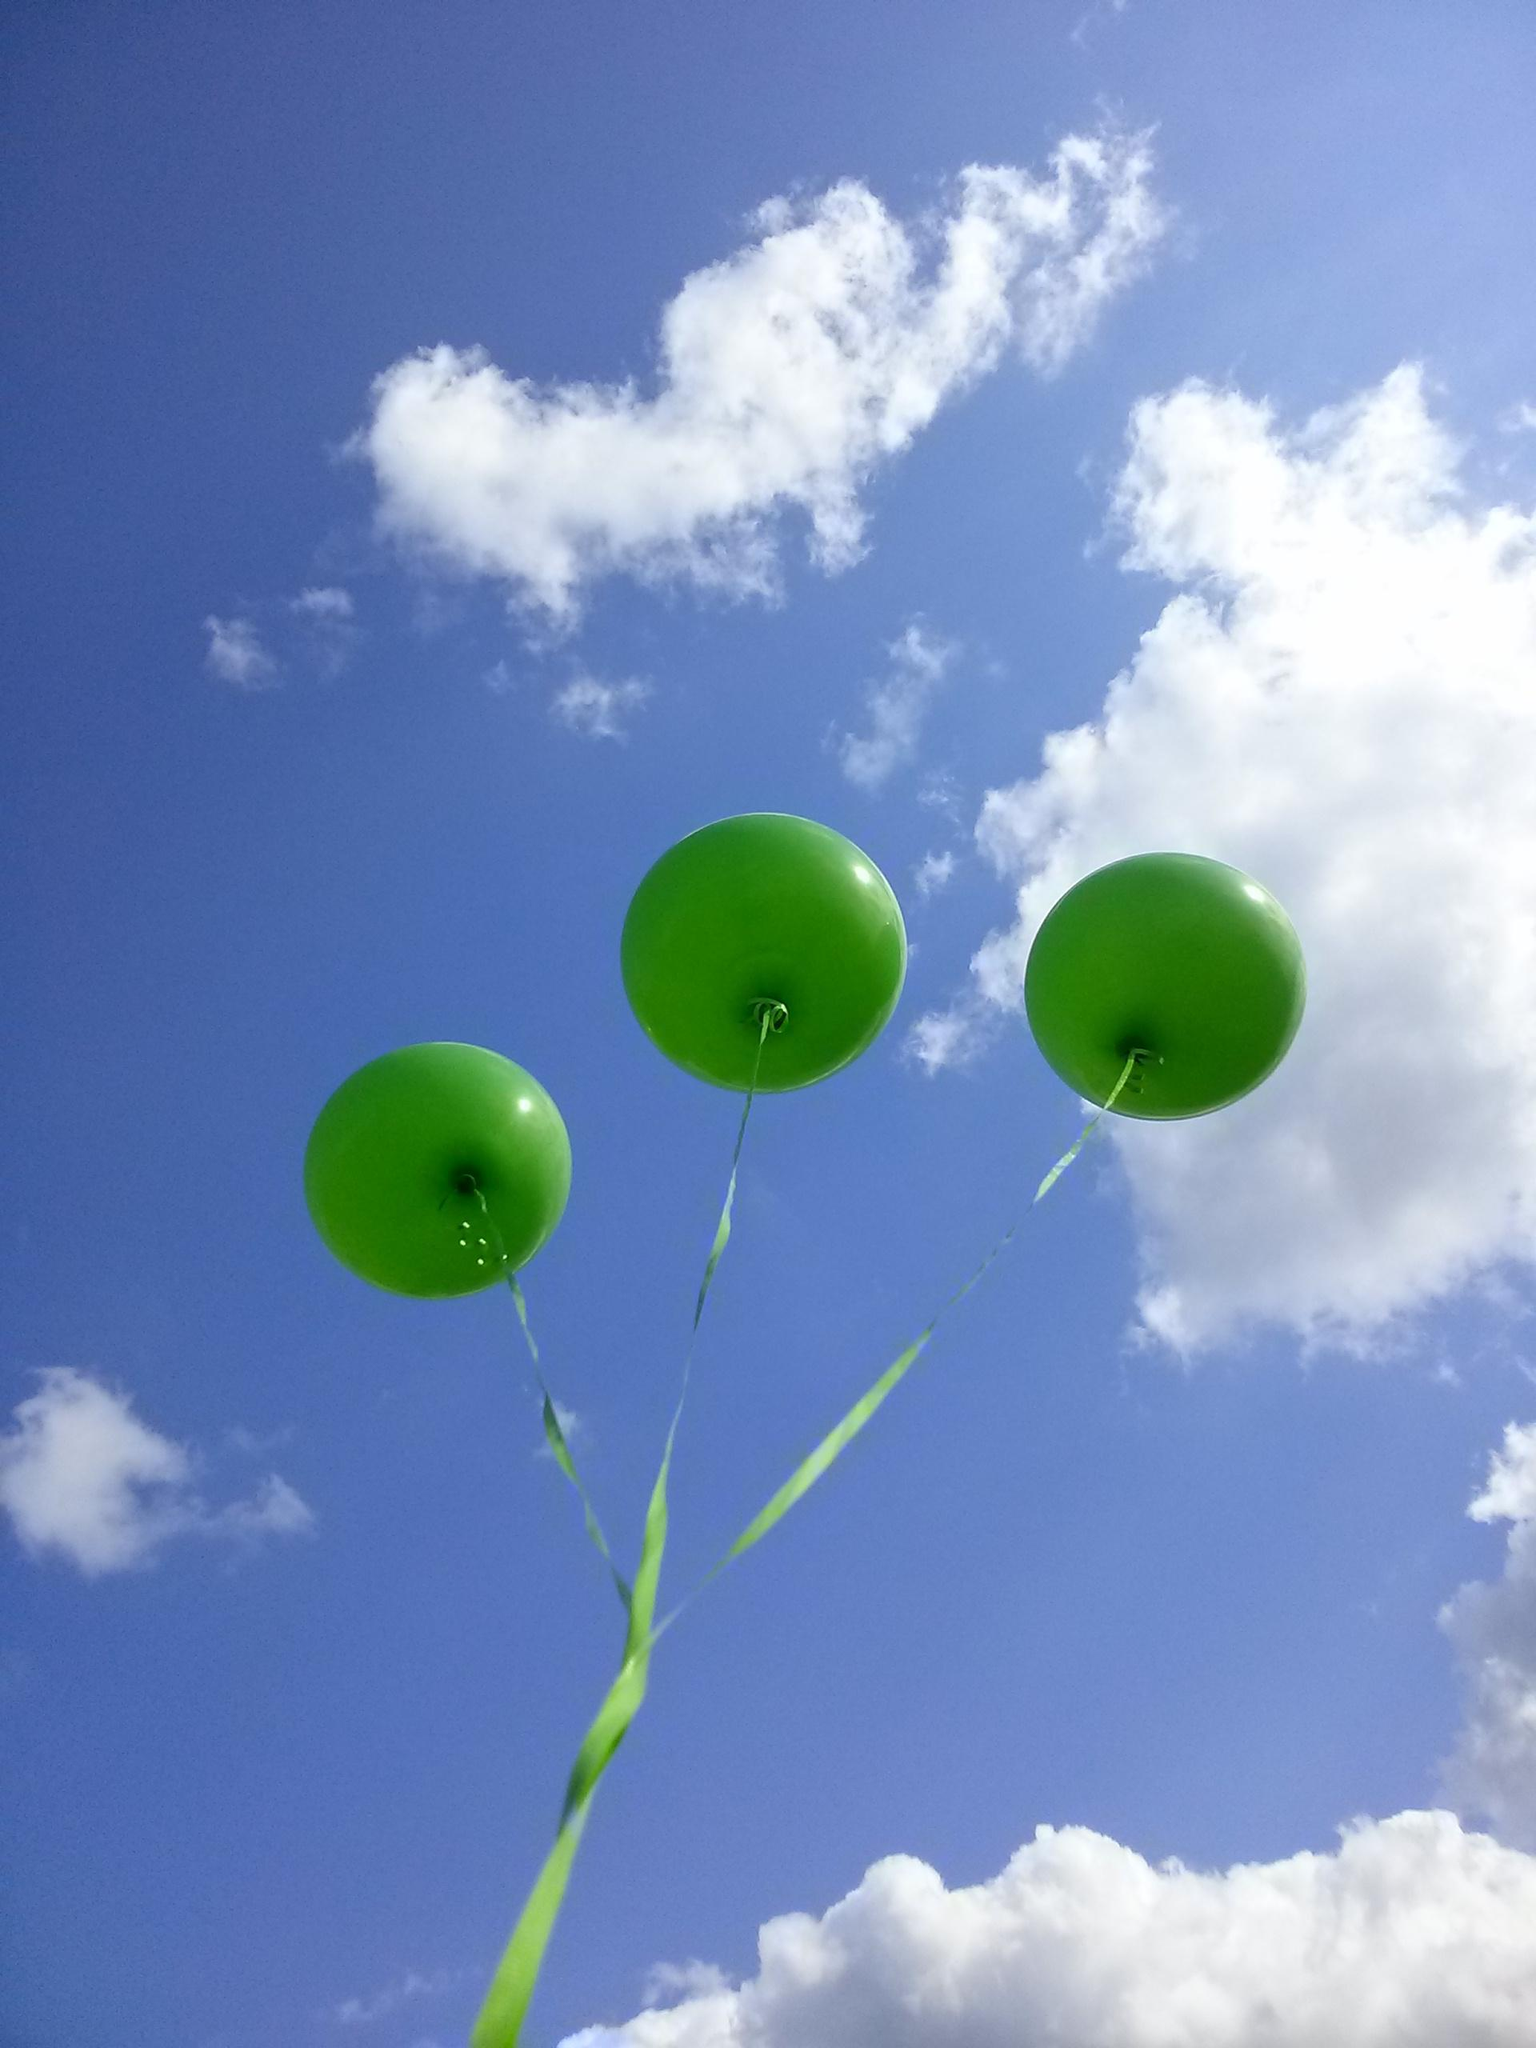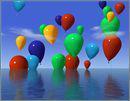The first image is the image on the left, the second image is the image on the right. For the images shown, is this caption "An image shows at least one person being lifted by means of balloon." true? Answer yes or no. No. The first image is the image on the left, the second image is the image on the right. Given the left and right images, does the statement "There are two other colored balloons with a yellow balloon in the right image." hold true? Answer yes or no. No. 